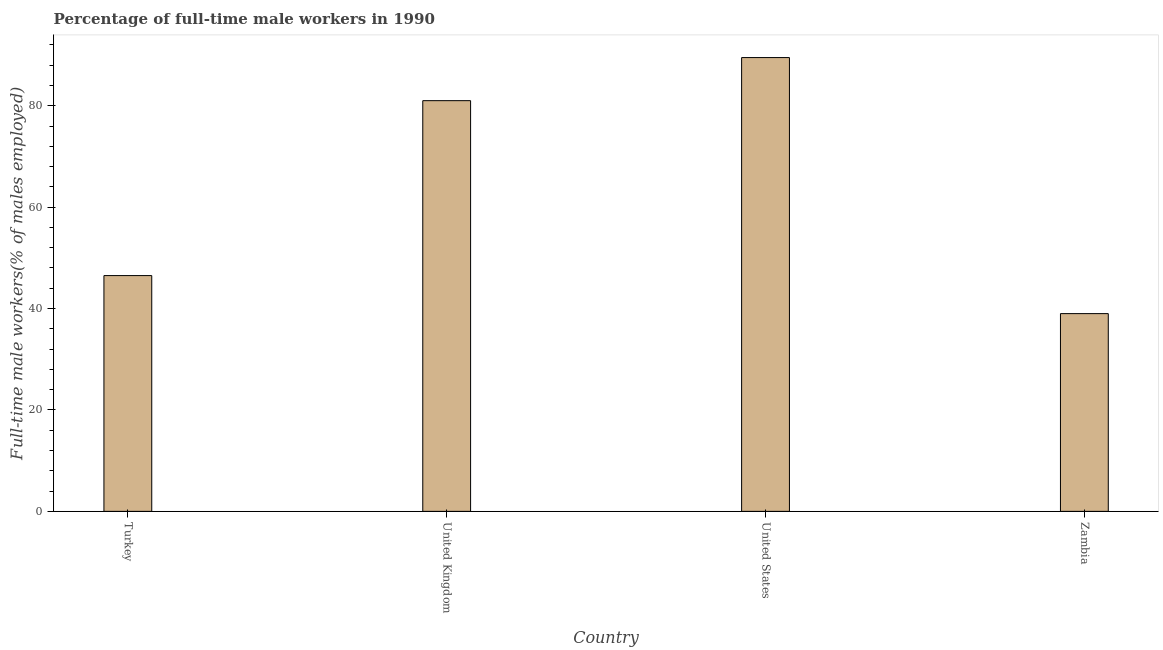What is the title of the graph?
Provide a succinct answer. Percentage of full-time male workers in 1990. What is the label or title of the X-axis?
Make the answer very short. Country. What is the label or title of the Y-axis?
Offer a very short reply. Full-time male workers(% of males employed). Across all countries, what is the maximum percentage of full-time male workers?
Give a very brief answer. 89.5. Across all countries, what is the minimum percentage of full-time male workers?
Your answer should be compact. 39. In which country was the percentage of full-time male workers minimum?
Ensure brevity in your answer.  Zambia. What is the sum of the percentage of full-time male workers?
Make the answer very short. 256. What is the median percentage of full-time male workers?
Your answer should be very brief. 63.75. In how many countries, is the percentage of full-time male workers greater than 88 %?
Make the answer very short. 1. What is the ratio of the percentage of full-time male workers in United Kingdom to that in United States?
Give a very brief answer. 0.91. Is the percentage of full-time male workers in Turkey less than that in United States?
Provide a short and direct response. Yes. What is the difference between the highest and the second highest percentage of full-time male workers?
Offer a terse response. 8.5. Is the sum of the percentage of full-time male workers in United Kingdom and Zambia greater than the maximum percentage of full-time male workers across all countries?
Your answer should be very brief. Yes. What is the difference between the highest and the lowest percentage of full-time male workers?
Offer a terse response. 50.5. Are all the bars in the graph horizontal?
Provide a short and direct response. No. What is the difference between two consecutive major ticks on the Y-axis?
Provide a succinct answer. 20. Are the values on the major ticks of Y-axis written in scientific E-notation?
Offer a very short reply. No. What is the Full-time male workers(% of males employed) in Turkey?
Give a very brief answer. 46.5. What is the Full-time male workers(% of males employed) in United States?
Give a very brief answer. 89.5. What is the Full-time male workers(% of males employed) in Zambia?
Give a very brief answer. 39. What is the difference between the Full-time male workers(% of males employed) in Turkey and United Kingdom?
Provide a succinct answer. -34.5. What is the difference between the Full-time male workers(% of males employed) in Turkey and United States?
Your answer should be very brief. -43. What is the difference between the Full-time male workers(% of males employed) in United Kingdom and Zambia?
Provide a succinct answer. 42. What is the difference between the Full-time male workers(% of males employed) in United States and Zambia?
Offer a terse response. 50.5. What is the ratio of the Full-time male workers(% of males employed) in Turkey to that in United Kingdom?
Your response must be concise. 0.57. What is the ratio of the Full-time male workers(% of males employed) in Turkey to that in United States?
Offer a terse response. 0.52. What is the ratio of the Full-time male workers(% of males employed) in Turkey to that in Zambia?
Your response must be concise. 1.19. What is the ratio of the Full-time male workers(% of males employed) in United Kingdom to that in United States?
Ensure brevity in your answer.  0.91. What is the ratio of the Full-time male workers(% of males employed) in United Kingdom to that in Zambia?
Offer a very short reply. 2.08. What is the ratio of the Full-time male workers(% of males employed) in United States to that in Zambia?
Give a very brief answer. 2.29. 